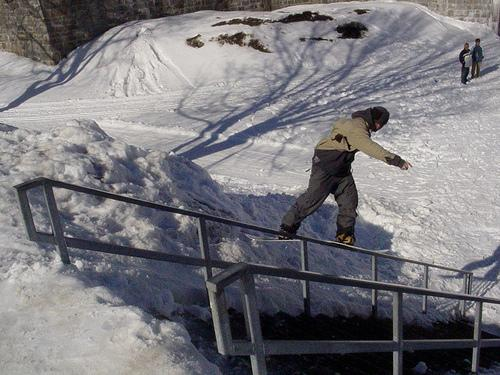What move is the snowboarder doing? grind 